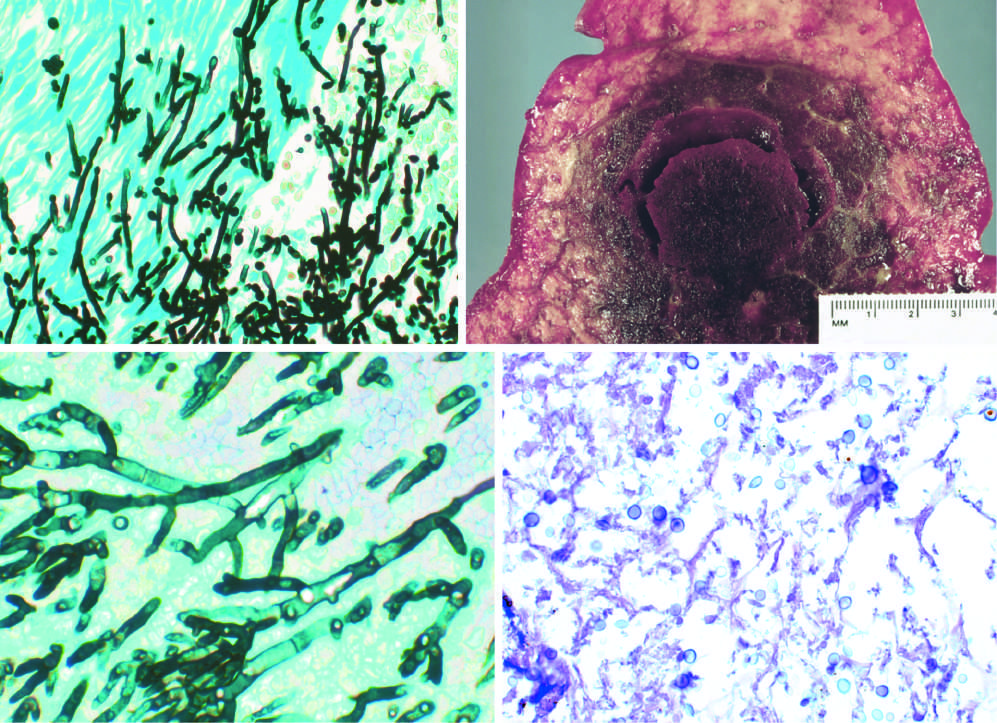does acute cellular rejection of a kidney graft have pseudohyphae and budding yeasts silver stain?
Answer the question using a single word or phrase. No 